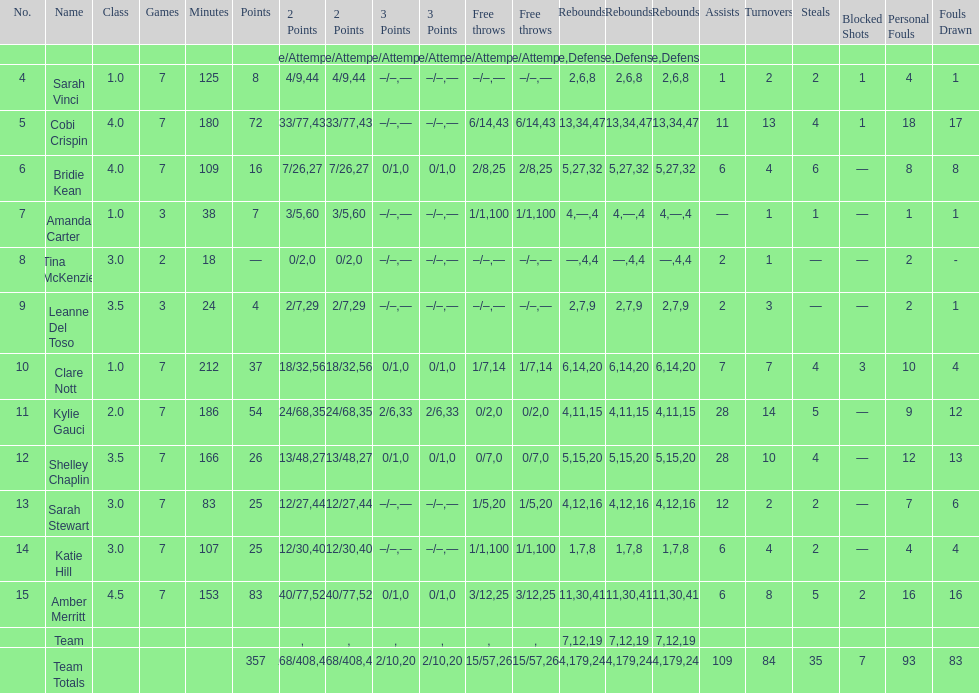Help me parse the entirety of this table. {'header': ['No.', 'Name', 'Class', 'Games', 'Minutes', 'Points', '2 Points', '2 Points', '3 Points', '3 Points', 'Free throws', 'Free throws', 'Rebounds', 'Rebounds', 'Rebounds', 'Assists', 'Turnovers', 'Steals', 'Blocked Shots', 'Personal Fouls', 'Fouls Drawn'], 'rows': [['', '', '', '', '', '', 'Made/Attempts', '%', 'Made/Attempts', '%', 'Made/Attempts', '%', 'Offensive', 'Defensive', 'Total', '', '', '', '', '', ''], ['4', 'Sarah Vinci', '1.0', '7', '125', '8', '4/9', '44', '–/–', '—', '–/–', '—', '2', '6', '8', '1', '2', '2', '1', '4', '1'], ['5', 'Cobi Crispin', '4.0', '7', '180', '72', '33/77', '43', '–/–', '—', '6/14', '43', '13', '34', '47', '11', '13', '4', '1', '18', '17'], ['6', 'Bridie Kean', '4.0', '7', '109', '16', '7/26', '27', '0/1', '0', '2/8', '25', '5', '27', '32', '6', '4', '6', '—', '8', '8'], ['7', 'Amanda Carter', '1.0', '3', '38', '7', '3/5', '60', '–/–', '—', '1/1', '100', '4', '—', '4', '—', '1', '1', '—', '1', '1'], ['8', 'Tina McKenzie', '3.0', '2', '18', '—', '0/2', '0', '–/–', '—', '–/–', '—', '—', '4', '4', '2', '1', '—', '—', '2', '-'], ['9', 'Leanne Del Toso', '3.5', '3', '24', '4', '2/7', '29', '–/–', '—', '–/–', '—', '2', '7', '9', '2', '3', '—', '—', '2', '1'], ['10', 'Clare Nott', '1.0', '7', '212', '37', '18/32', '56', '0/1', '0', '1/7', '14', '6', '14', '20', '7', '7', '4', '3', '10', '4'], ['11', 'Kylie Gauci', '2.0', '7', '186', '54', '24/68', '35', '2/6', '33', '0/2', '0', '4', '11', '15', '28', '14', '5', '—', '9', '12'], ['12', 'Shelley Chaplin', '3.5', '7', '166', '26', '13/48', '27', '0/1', '0', '0/7', '0', '5', '15', '20', '28', '10', '4', '—', '12', '13'], ['13', 'Sarah Stewart', '3.0', '7', '83', '25', '12/27', '44', '–/–', '—', '1/5', '20', '4', '12', '16', '12', '2', '2', '—', '7', '6'], ['14', 'Katie Hill', '3.0', '7', '107', '25', '12/30', '40', '–/–', '—', '1/1', '100', '1', '7', '8', '6', '4', '2', '—', '4', '4'], ['15', 'Amber Merritt', '4.5', '7', '153', '83', '40/77', '52', '0/1', '0', '3/12', '25', '11', '30', '41', '6', '8', '5', '2', '16', '16'], ['', 'Team', '', '', '', '', '', '', '', '', '', '', '7', '12', '19', '', '', '', '', '', ''], ['', 'Team Totals', '', '', '', '357', '168/408', '41', '2/10', '20', '15/57', '26', '64', '179', '243', '109', '84', '35', '7', '93', '83']]} Who is the first person on the list to play less than 20 minutes? Tina McKenzie. 